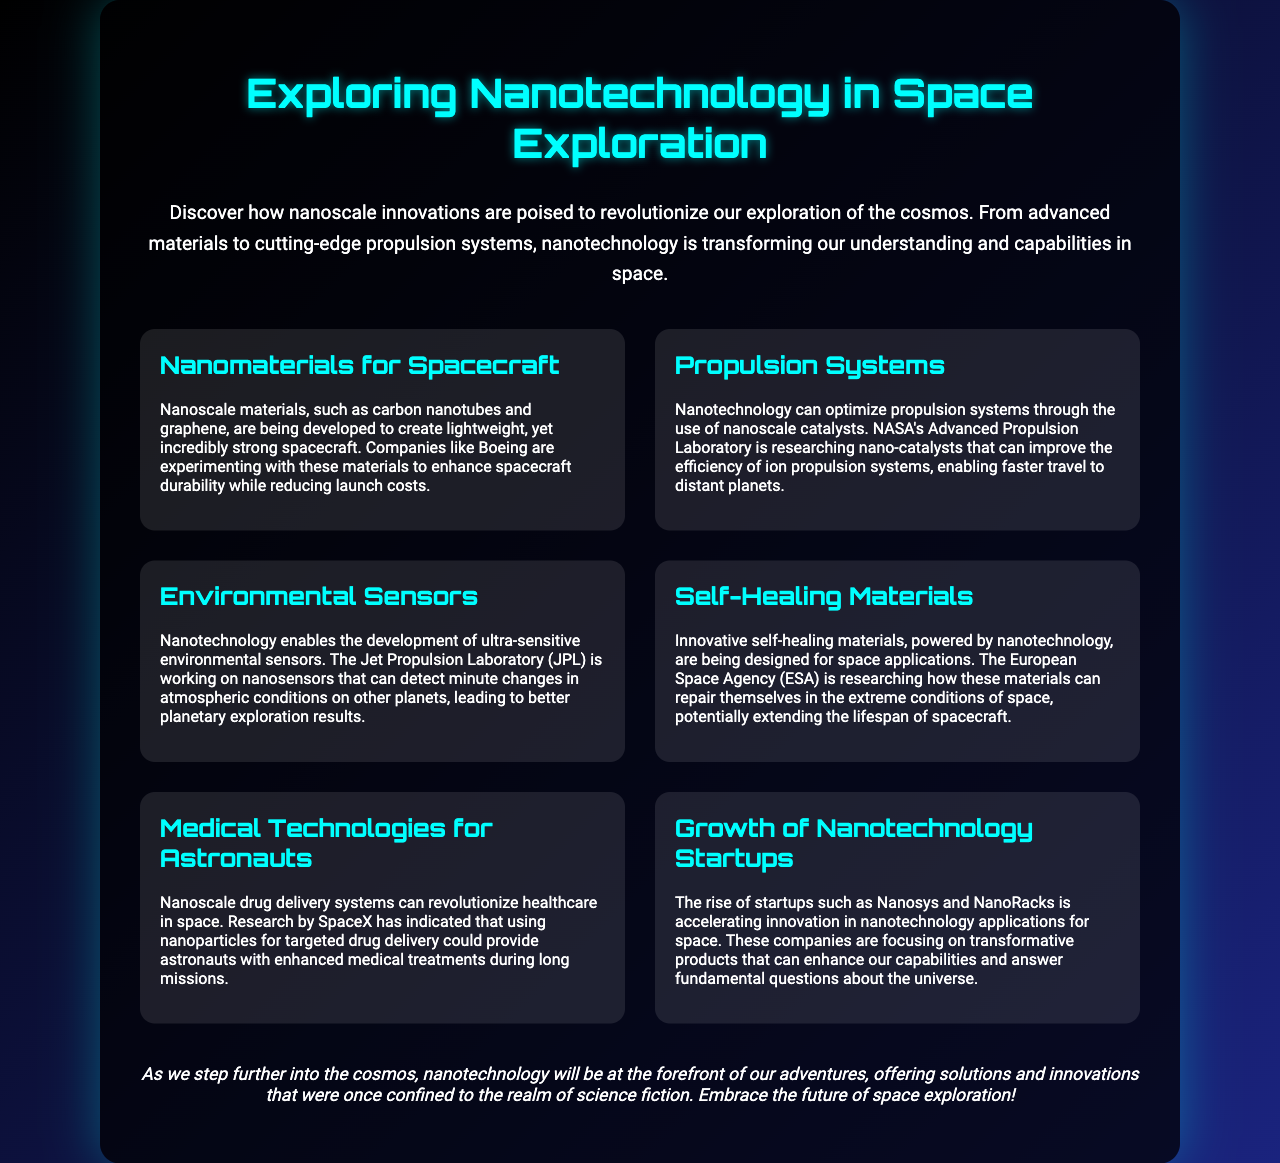What is the title of the brochure? The title of the brochure is the main heading that introduces the topic of discussion, which is found prominently at the top of the document.
Answer: Exploring Nanotechnology in Space Exploration What are carbon nanotubes and graphene used for? These are types of nanoscale materials mentioned for their strength and lightweight properties in spacecraft development.
Answer: Lightweight, yet incredibly strong spacecraft Which organization is researching nano-catalysts for propulsion systems? The specific laboratory working on this research is mentioned in the context of improving ion propulsion systems.
Answer: NASA's Advanced Propulsion Laboratory What is the purpose of nanosensors developed by JPL? The nanosensors are designed to detect specific changes, as stated in the section discussing their applications in planetary exploration.
Answer: Detect minute changes in atmospheric conditions What type of materials is the European Space Agency researching? The document specifies innovative materials that can repair themselves and are crucial for applications in harsh environments.
Answer: Self-healing materials Which company is indicated to explore nanoscale drug delivery systems for astronauts? This company is highlighted for its innovative approach to healthcare during long space missions, focusing on drug delivery.
Answer: SpaceX How are startups like Nanosys and NanoRacks contributing? The brochure states that these startups are accelerating innovation in a specific area of technology related to space exploration.
Answer: Transformative products in nanotechnology applications What is the main theme of the conclusion? The concluding remarks encapsulate the overarching narrative about the role of nanotechnology in future space exploration efforts.
Answer: Nanotechnology will be at the forefront of our adventures 